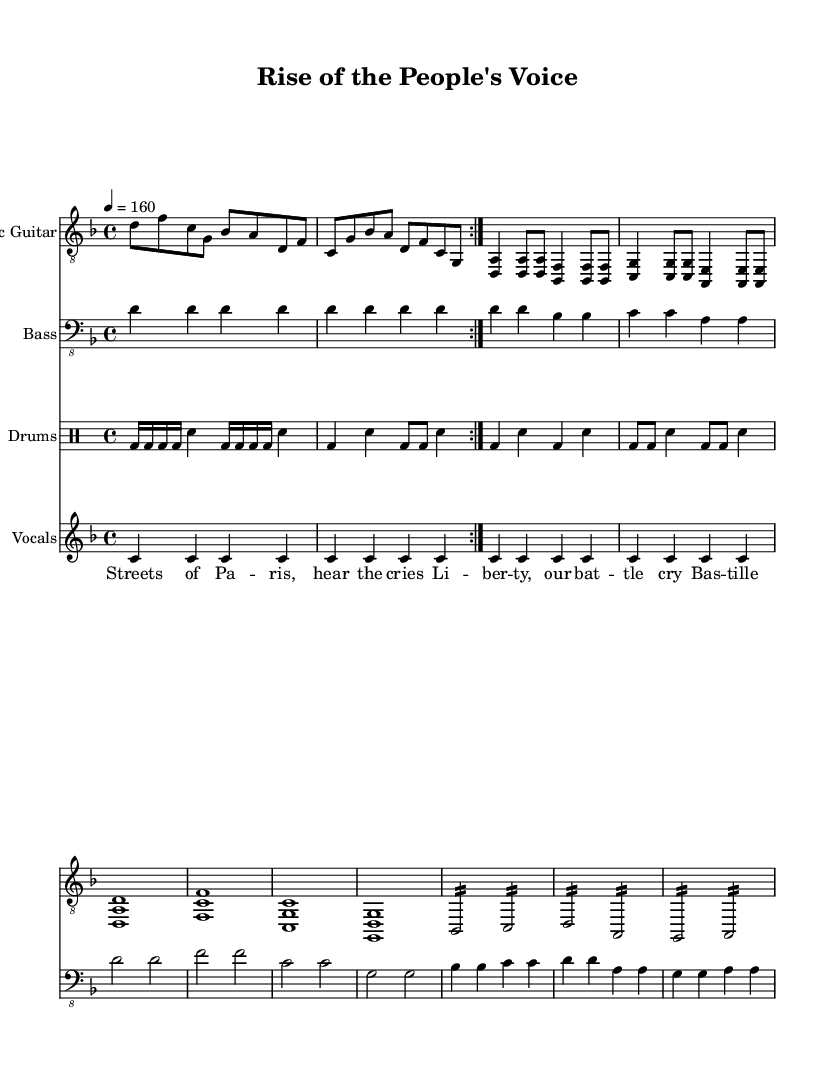What is the key signature of this music? The key signature is marked at the beginning of the sheet music, showing two flats, which indicates the scale being used for the piece.
Answer: D minor What is the time signature of this music? The time signature appears at the beginning of the sheet music, specified as 4/4, which means there are four beats per measure and a quarter note gets one beat.
Answer: 4/4 What is the tempo marking indicated in the sheet music? The tempo marking is specified within the sheet music, indicating a speed of 160 beats per minute (bpm) for the piece.
Answer: 160 How many measures are in the verse section? By analyzing the verse section, which consists of repeated patterns, you can count the measures explicitly written out. The verse consists of a total of 8 measures, as indicated.
Answer: 8 What instrument plays the main riff at the start? The main riff at the beginning of the composition is indicated to be played on the electric guitar, specified clearly in the staff designation.
Answer: Electric Guitar How does the lyric content relate to the historical theme of the song? The lyrical content refers to the French Revolution, with phrases like "Streets of Paris" and "Bastille falls," capturing the essence of revolutionary struggles and the quest for liberty.
Answer: French Revolution What is the first chord played in the electric guitar's intro? The first chord in the electric guitar's intro section is shown explicitly in the sheet music, making it identifiable. This chord is D minor, which is typically represented in the staff notation.
Answer: D minor 